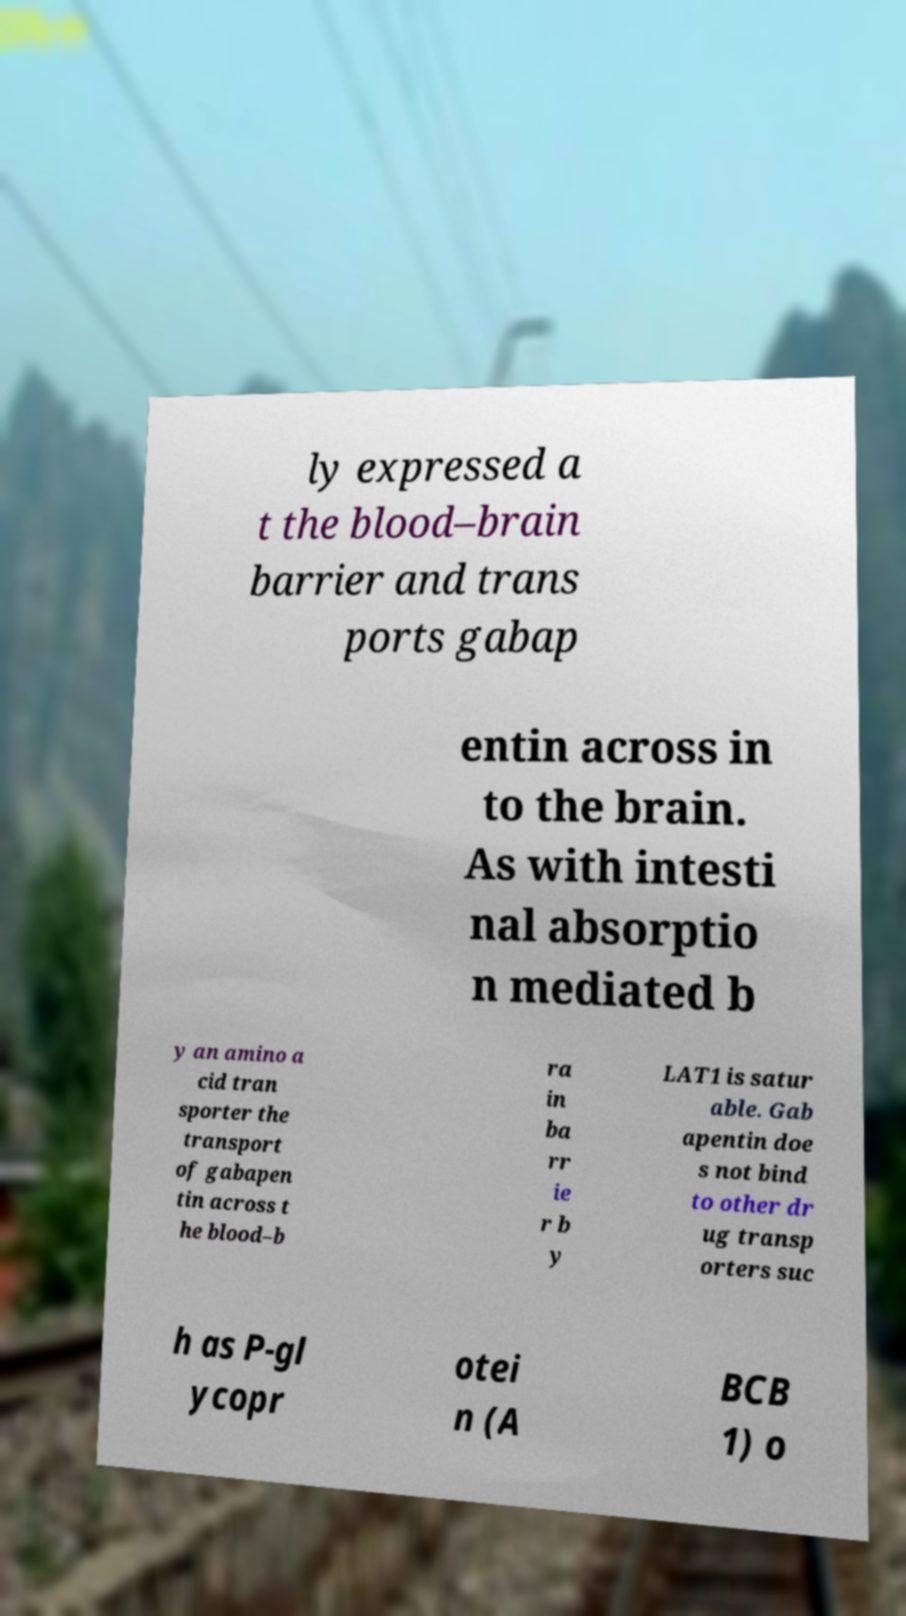Please identify and transcribe the text found in this image. ly expressed a t the blood–brain barrier and trans ports gabap entin across in to the brain. As with intesti nal absorptio n mediated b y an amino a cid tran sporter the transport of gabapen tin across t he blood–b ra in ba rr ie r b y LAT1 is satur able. Gab apentin doe s not bind to other dr ug transp orters suc h as P-gl ycopr otei n (A BCB 1) o 